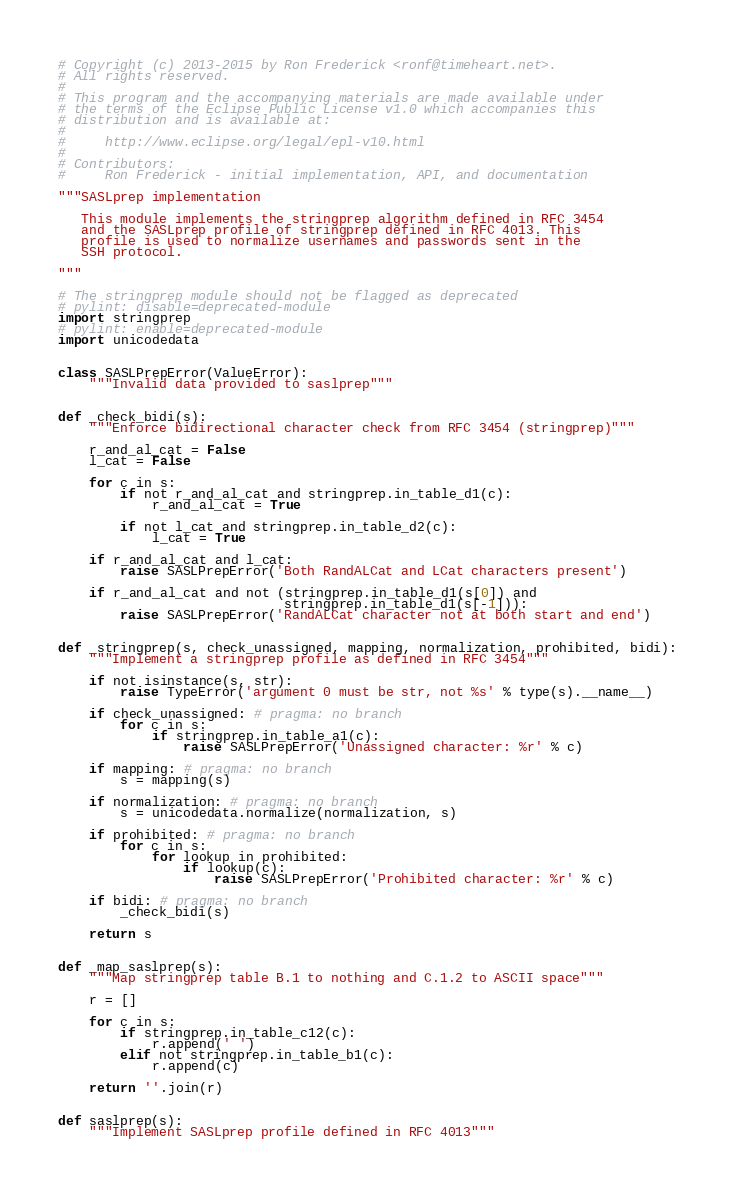<code> <loc_0><loc_0><loc_500><loc_500><_Python_># Copyright (c) 2013-2015 by Ron Frederick <ronf@timeheart.net>.
# All rights reserved.
#
# This program and the accompanying materials are made available under
# the terms of the Eclipse Public License v1.0 which accompanies this
# distribution and is available at:
#
#     http://www.eclipse.org/legal/epl-v10.html
#
# Contributors:
#     Ron Frederick - initial implementation, API, and documentation

"""SASLprep implementation

   This module implements the stringprep algorithm defined in RFC 3454
   and the SASLprep profile of stringprep defined in RFC 4013. This
   profile is used to normalize usernames and passwords sent in the
   SSH protocol.

"""

# The stringprep module should not be flagged as deprecated
# pylint: disable=deprecated-module
import stringprep
# pylint: enable=deprecated-module
import unicodedata


class SASLPrepError(ValueError):
    """Invalid data provided to saslprep"""


def _check_bidi(s):
    """Enforce bidirectional character check from RFC 3454 (stringprep)"""

    r_and_al_cat = False
    l_cat = False

    for c in s:
        if not r_and_al_cat and stringprep.in_table_d1(c):
            r_and_al_cat = True

        if not l_cat and stringprep.in_table_d2(c):
            l_cat = True

    if r_and_al_cat and l_cat:
        raise SASLPrepError('Both RandALCat and LCat characters present')

    if r_and_al_cat and not (stringprep.in_table_d1(s[0]) and
                             stringprep.in_table_d1(s[-1])):
        raise SASLPrepError('RandALCat character not at both start and end')


def _stringprep(s, check_unassigned, mapping, normalization, prohibited, bidi):
    """Implement a stringprep profile as defined in RFC 3454"""

    if not isinstance(s, str):
        raise TypeError('argument 0 must be str, not %s' % type(s).__name__)

    if check_unassigned: # pragma: no branch
        for c in s:
            if stringprep.in_table_a1(c):
                raise SASLPrepError('Unassigned character: %r' % c)

    if mapping: # pragma: no branch
        s = mapping(s)

    if normalization: # pragma: no branch
        s = unicodedata.normalize(normalization, s)

    if prohibited: # pragma: no branch
        for c in s:
            for lookup in prohibited:
                if lookup(c):
                    raise SASLPrepError('Prohibited character: %r' % c)

    if bidi: # pragma: no branch
        _check_bidi(s)

    return s


def _map_saslprep(s):
    """Map stringprep table B.1 to nothing and C.1.2 to ASCII space"""

    r = []

    for c in s:
        if stringprep.in_table_c12(c):
            r.append(' ')
        elif not stringprep.in_table_b1(c):
            r.append(c)

    return ''.join(r)


def saslprep(s):
    """Implement SASLprep profile defined in RFC 4013"""
</code> 